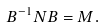<formula> <loc_0><loc_0><loc_500><loc_500>B ^ { - 1 } N B = M .</formula> 